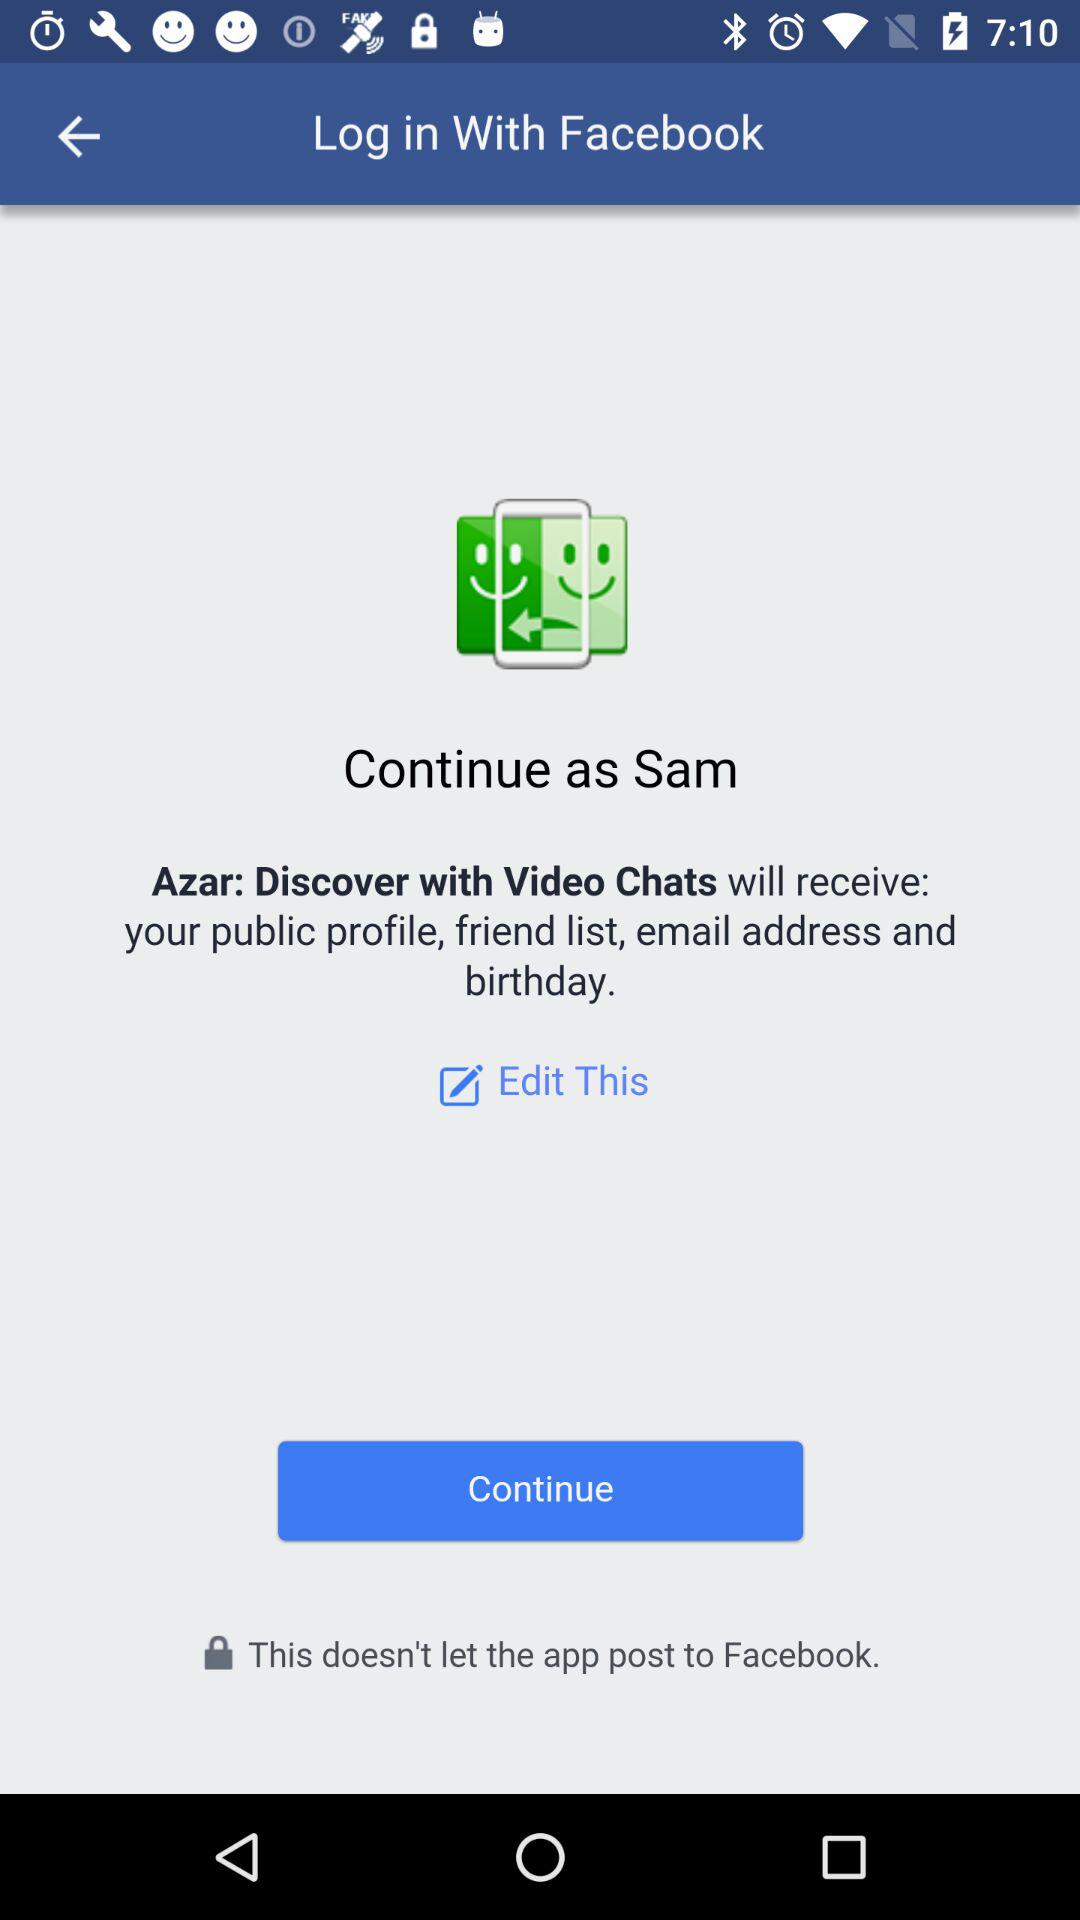What is the name of the user? The name of the user is Sam. 